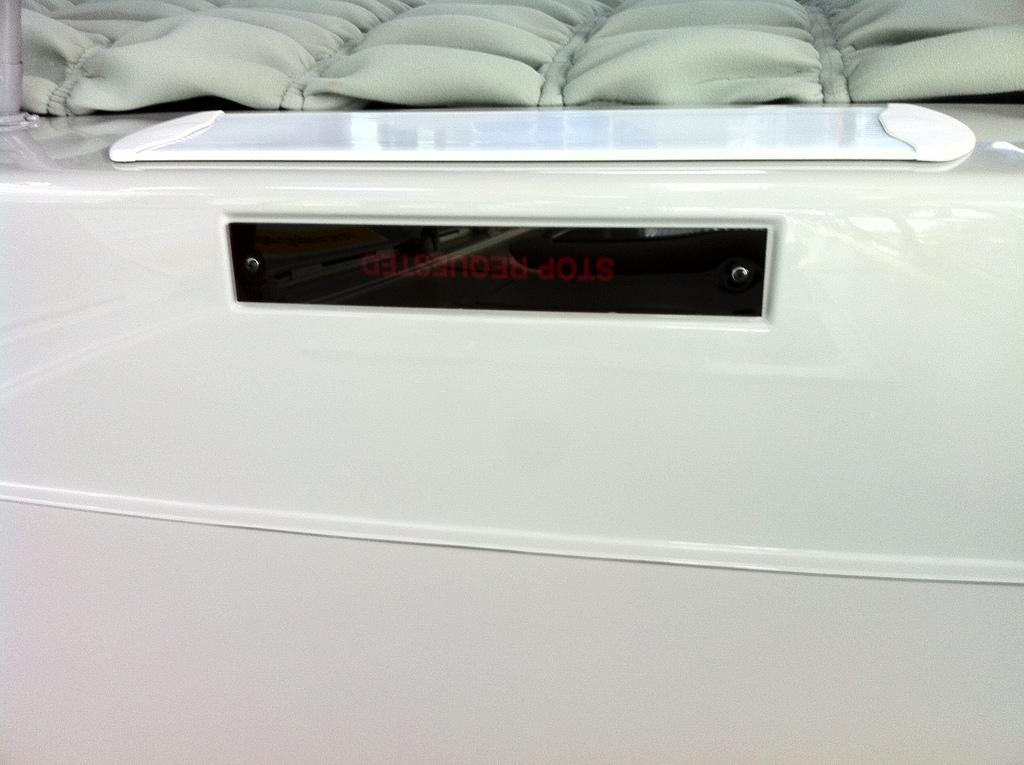What type of board is present in the image? There is a whiteboard and a digital board in the image. Can you describe the appearance of the whiteboard? The whiteboard is a flat surface that is typically used for writing or displaying information. How does the digital board differ from the whiteboard? The digital board is likely an electronic device that can display digital content, such as images or videos. How does the bee feel about the potato in the image? There are no bees or potatoes present in the image, so it is not possible to answer that question. 